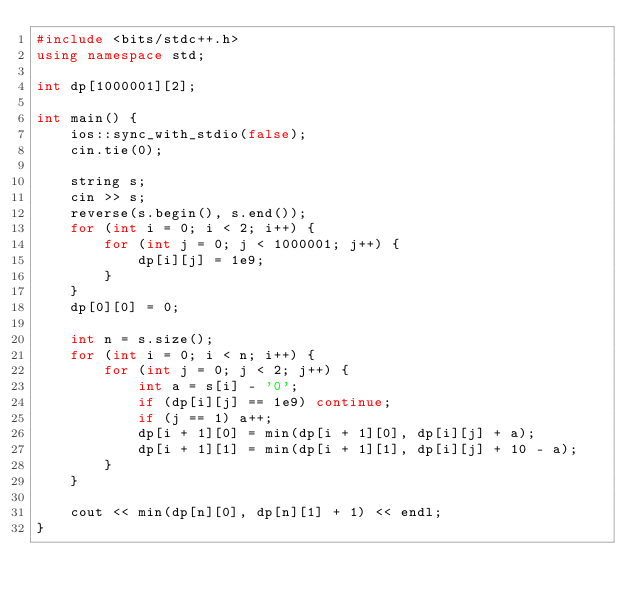<code> <loc_0><loc_0><loc_500><loc_500><_C++_>#include <bits/stdc++.h>
using namespace std;

int dp[1000001][2];

int main() {
    ios::sync_with_stdio(false);
    cin.tie(0);

    string s;
    cin >> s;
    reverse(s.begin(), s.end());
    for (int i = 0; i < 2; i++) {
        for (int j = 0; j < 1000001; j++) {
            dp[i][j] = 1e9;
        }
    }
    dp[0][0] = 0;

    int n = s.size();
    for (int i = 0; i < n; i++) {
        for (int j = 0; j < 2; j++) {
            int a = s[i] - '0';
            if (dp[i][j] == 1e9) continue;
            if (j == 1) a++;
            dp[i + 1][0] = min(dp[i + 1][0], dp[i][j] + a);
            dp[i + 1][1] = min(dp[i + 1][1], dp[i][j] + 10 - a);
        }
    }

    cout << min(dp[n][0], dp[n][1] + 1) << endl;
}
</code> 